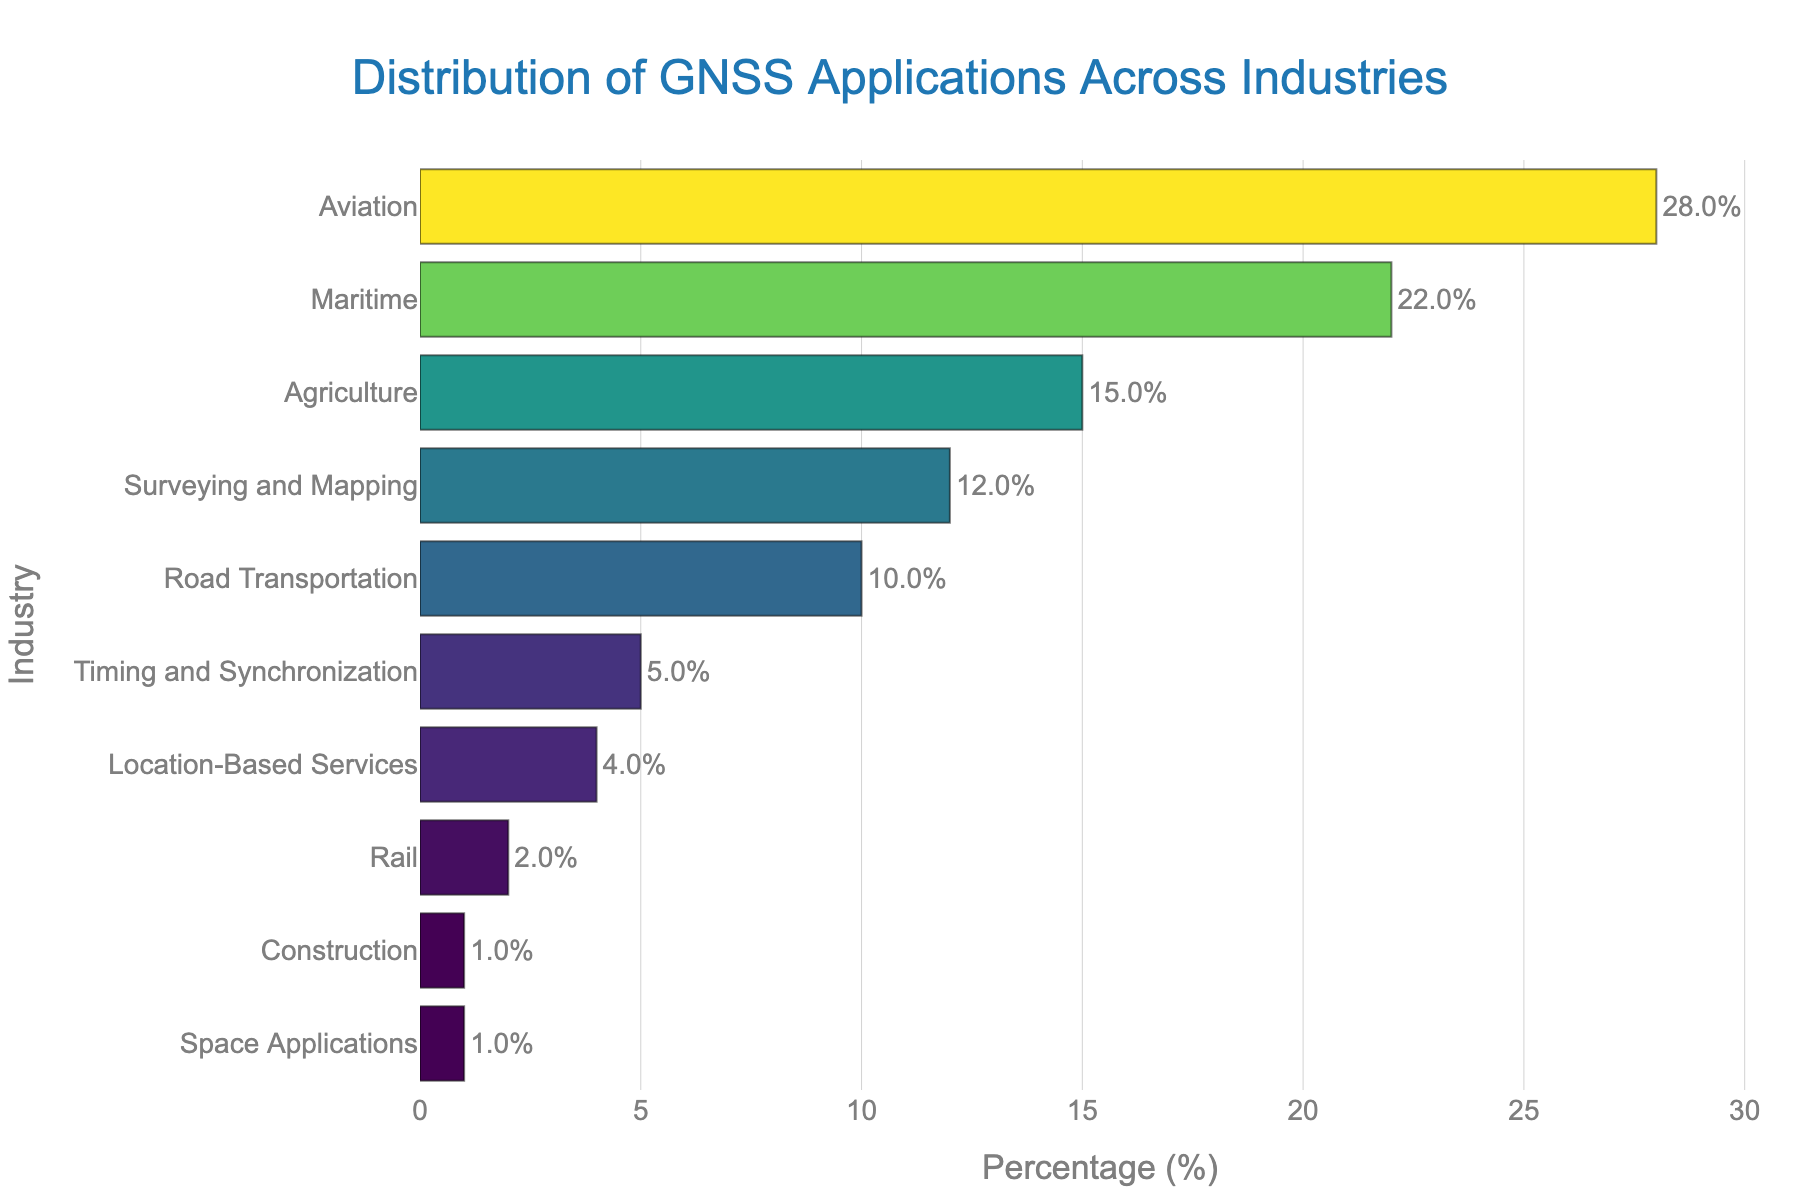Which industry has the highest percentage of GNSS applications? Look at the bar with the longest length and highest percentage value.
Answer: Aviation Which two industries combined have a GNSS application distribution percentage closest to 50%? Add up the percentages for various combinations of two industries. The combination of Aviation (28%) and Maritime (22%) sums up to 50%.
Answer: Aviation and Maritime What’s the difference in GNSS application percentage between Road Transportation and Surveying and Mapping? Subtract the percentage of GNSS applications in Road Transportation (10%) from that in Surveying and Mapping (12%).
Answer: 2% Is the percentage of GNSS applications in Agriculture greater than that in Road Transportation? Compare the percentages: Agriculture is 15% and Road Transportation is 10%.
Answer: Yes What is the combined percentage of GNSS applications in industries with less than 5% each? Add the percentages of Location-Based Services (4%), Rail (2%), Construction (1%), and Space Applications (1%).
Answer: 8% Which industry has the least percentage of GNSS applications? Identify the bar with the smallest percentage value.
Answer: Construction and Space Applications (tie) How much greater is the GNSS application percentage in Maritime compared to Agriculture? Subtract Agriculture's percentage (15%) from Maritime's percentage (22%).
Answer: 7% What is the range of GNSS application percentages across all industries? Subtract the smallest percentage (1%) from the largest percentage (28%).
Answer: 27% What percentage of GNSS applications does the top three industries combined constitute? Add the percentages of Aviation (28%), Maritime (22%), and Agriculture (15%).
Answer: 65% How many industries have a GNSS application percentage that is equal to or higher than 10%? Count the bars with percentages 10% or higher: Aviation (28%), Maritime (22%), Agriculture (15%), and Surveying and Mapping (12%).
Answer: 4 